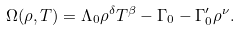Convert formula to latex. <formula><loc_0><loc_0><loc_500><loc_500>\Omega ( \rho , T ) = \Lambda _ { 0 } \rho ^ { \delta } T ^ { \beta } - \Gamma _ { 0 } - \Gamma _ { 0 } ^ { \prime } \rho ^ { \nu } .</formula> 